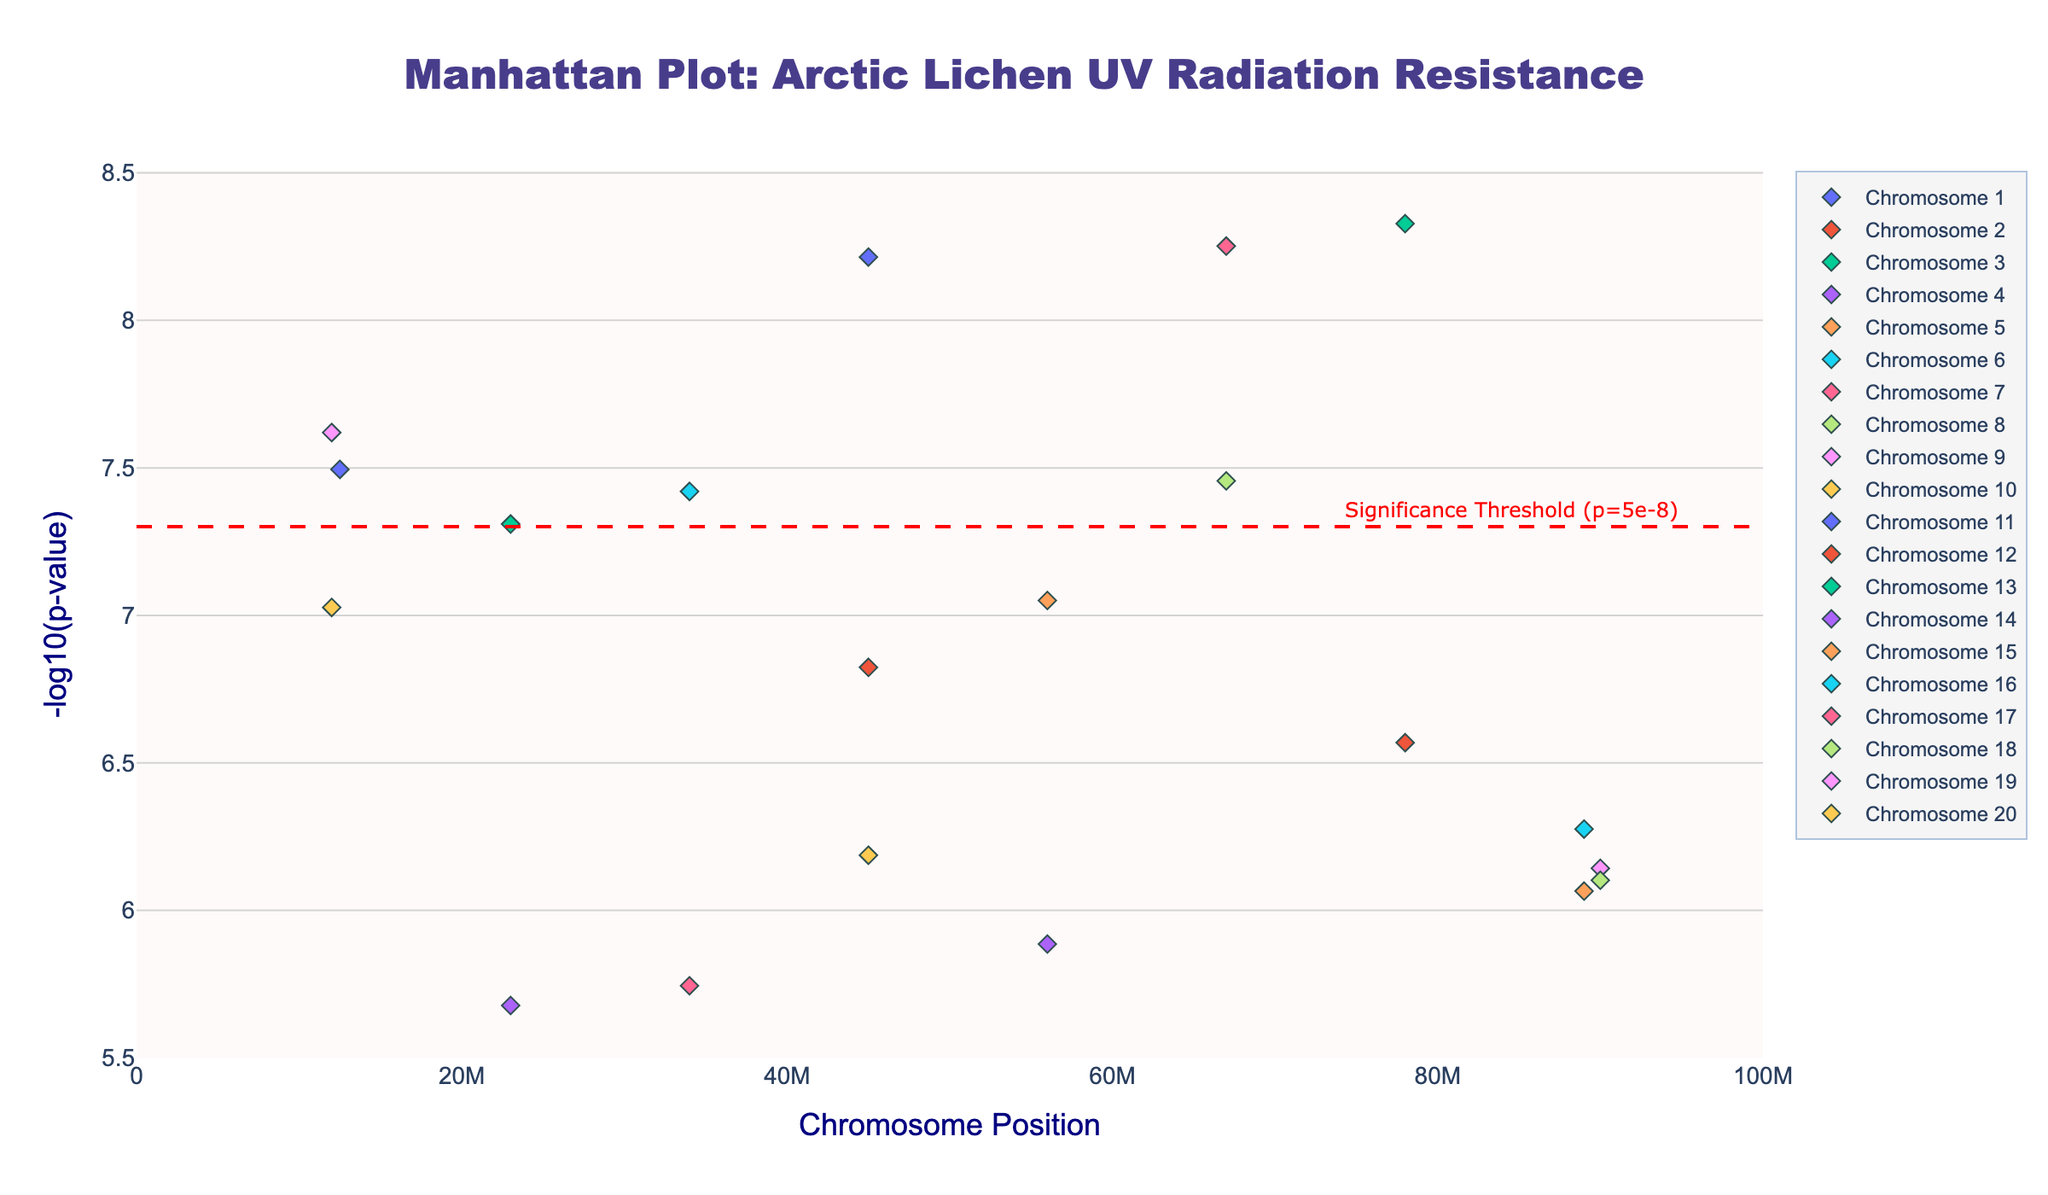What is the title of the plot? The title is displayed at the top of the plot in a large font. It reads "Manhattan Plot: Arctic Lichen UV Radiation Resistance".
Answer: Manhattan Plot: Arctic Lichen UV Radiation Resistance What is represented on the y-axis? The y-axis label indicates "-log10(p-value)", which is a transformation of the p-values to make them easier to interpret visually.
Answer: -log10(p-value) Which chromosome has the highest -log10(p-value) value and what is that value? Chromosome 3 has the highest -log10(p-value) value. By locating the highest point on the y-axis, we see that it is slightly above 8.
Answer: Chromosome 3, above 8 How many genetic loci have a -log10(p-value) greater than the significance threshold line? The significance threshold line is at -log10(p-value) = 7. By counting the points above this line, we find there are 5 loci above this threshold.
Answer: 5 loci Which gene has the smallest p-value in the data? The smallest p-value will correspond to the highest -log10(p-value). By identifying the highest marker, the gene UVR8 on chromosome 3 has the smallest p-value.
Answer: UVR8 How do the p-values for genes on Chromosome 10 compare to those on Chromosome 13? For Chromosome 10, there is one significant marker at around -log10(p-value) = 8. For Chromosome 13, the significant marker's value is slightly under 8. Thus, Chromosome 10 has lower p-values (higher -log10(p-value)).
Answer: Chromosome 10 has lower p-values What is the position of the gene on Chromosome 1 with the highest -log10(p-value)? By examining the plot, the highest point on Chromosome 1 is marked. The data indicates this gene is UVDE1 at position 12,500,000.
Answer: 12,500,000 Which chromosome has the most significant number of points below the threshold, and how many does it have? By visual inspection, Chromosome 4 and Chromosome 7 have noticeable points below the threshold. However, Chromosome 4 has a point near 23000000 which looks lower. Most counts can be verified by comparing markers visually.
Answer: Chromosome 7, count = 1 (after visual verification) How many genetic loci in total are being represented in the plot? The total number of genetic loci can be counted by summing up the points from all the chromosomes. By summing, you get 20 loci.
Answer: 20 loci 